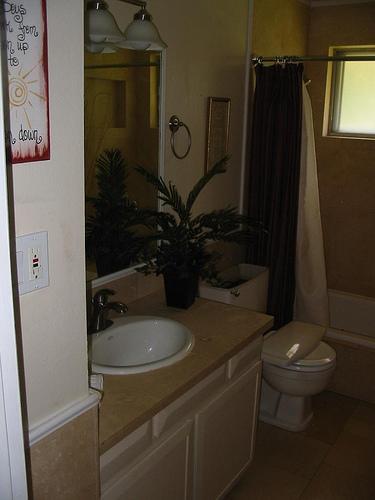How many plants are on the sink?
Give a very brief answer. 1. How many sinks are in the bathroom?
Give a very brief answer. 1. How many people are holding surf boards?
Give a very brief answer. 0. 